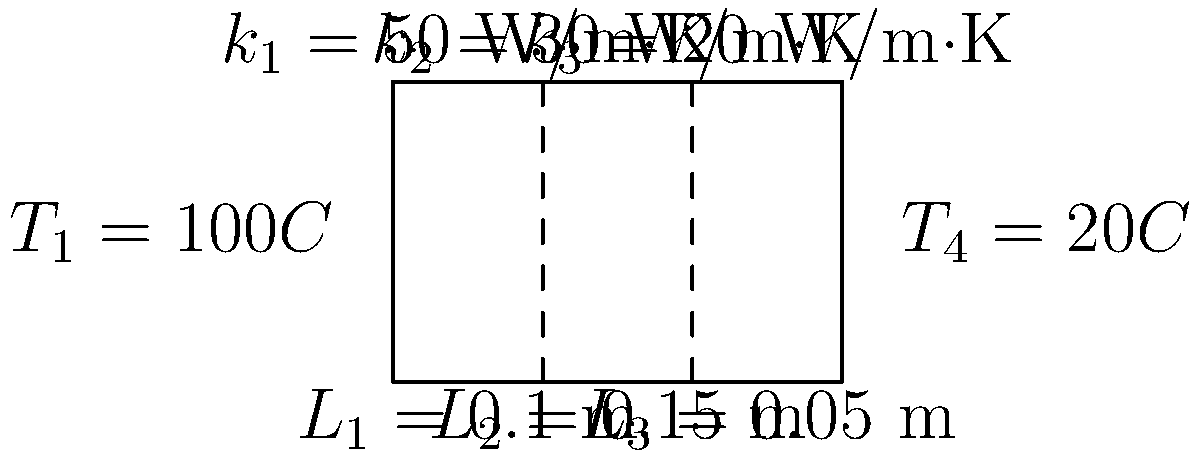During a quick break between meetings, you notice a composite wall in the office. The wall consists of three layers with different materials, as shown in the diagram. Given the temperatures on both sides of the wall and the thermal conductivities of each layer, calculate the heat transfer rate per unit area through the wall. Let's approach this step-by-step:

1) The heat transfer rate through a composite wall is given by the equation:

   $$q = \frac{T_1 - T_4}{\sum\frac{L_i}{k_i}}$$

   where $q$ is the heat transfer rate per unit area, $T_1$ and $T_4$ are the temperatures on either side of the wall, $L_i$ is the thickness of each layer, and $k_i$ is the thermal conductivity of each layer.

2) We need to calculate $\sum\frac{L_i}{k_i}$:

   $$\sum\frac{L_i}{k_i} = \frac{L_1}{k_1} + \frac{L_2}{k_2} + \frac{L_3}{k_3}$$

3) Substituting the values:

   $$\sum\frac{L_i}{k_i} = \frac{0.1}{50} + \frac{0.15}{30} + \frac{0.05}{20}$$

4) Calculating:

   $$\sum\frac{L_i}{k_i} = 0.002 + 0.005 + 0.0025 = 0.0095 \text{ m²·K/W}$$

5) Now we can calculate the heat transfer rate:

   $$q = \frac{T_1 - T_4}{\sum\frac{L_i}{k_i}} = \frac{100°C - 20°C}{0.0095 \text{ m²·K/W}}$$

6) Simplifying:

   $$q = \frac{80}{0.0095} = 8421.05 \text{ W/m²}$$

Therefore, the heat transfer rate per unit area through the wall is approximately 8421.05 W/m².
Answer: 8421.05 W/m² 